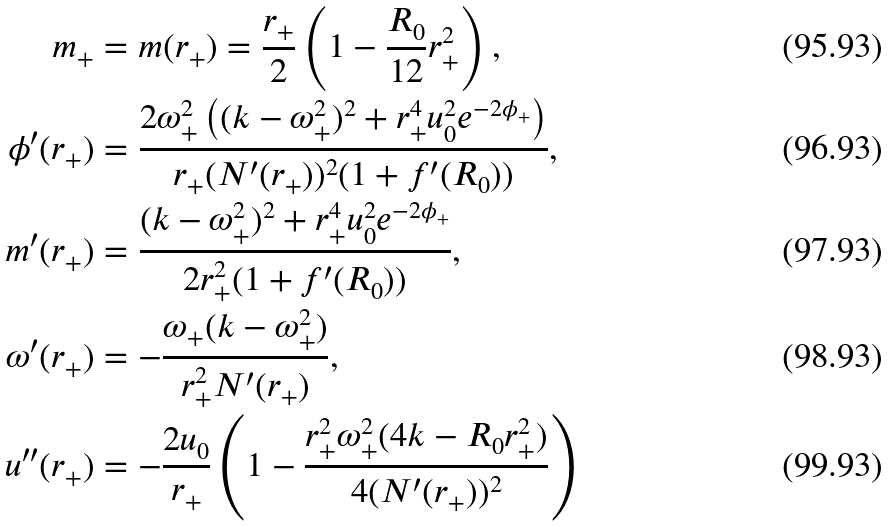<formula> <loc_0><loc_0><loc_500><loc_500>m _ { + } & = m ( r _ { + } ) = \frac { r _ { + } } { 2 } \left ( 1 - \frac { R _ { 0 } } { 1 2 } r _ { + } ^ { 2 } \right ) , \\ \phi ^ { \prime } ( r _ { + } ) & = \frac { 2 \omega _ { + } ^ { 2 } \left ( ( k - \omega _ { + } ^ { 2 } ) ^ { 2 } + r _ { + } ^ { 4 } u _ { 0 } ^ { 2 } e ^ { - 2 \phi _ { + } } \right ) } { r _ { + } ( N ^ { \prime } ( r _ { + } ) ) ^ { 2 } ( 1 + f ^ { \prime } ( R _ { 0 } ) ) } , \\ m ^ { \prime } ( r _ { + } ) & = \frac { ( k - \omega _ { + } ^ { 2 } ) ^ { 2 } + r _ { + } ^ { 4 } u _ { 0 } ^ { 2 } e ^ { - 2 \phi _ { + } } } { 2 r _ { + } ^ { 2 } ( 1 + f ^ { \prime } ( R _ { 0 } ) ) } , \\ \omega ^ { \prime } ( r _ { + } ) & = - \frac { \omega _ { + } ( k - \omega _ { + } ^ { 2 } ) } { r _ { + } ^ { 2 } N ^ { \prime } ( r _ { + } ) } , \\ u ^ { \prime \prime } ( r _ { + } ) & = - \frac { 2 u _ { 0 } } { r _ { + } } \left ( 1 - \frac { r _ { + } ^ { 2 } \omega _ { + } ^ { 2 } ( 4 k - R _ { 0 } r _ { + } ^ { 2 } ) } { 4 ( N ^ { \prime } ( r _ { + } ) ) ^ { 2 } } \right )</formula> 